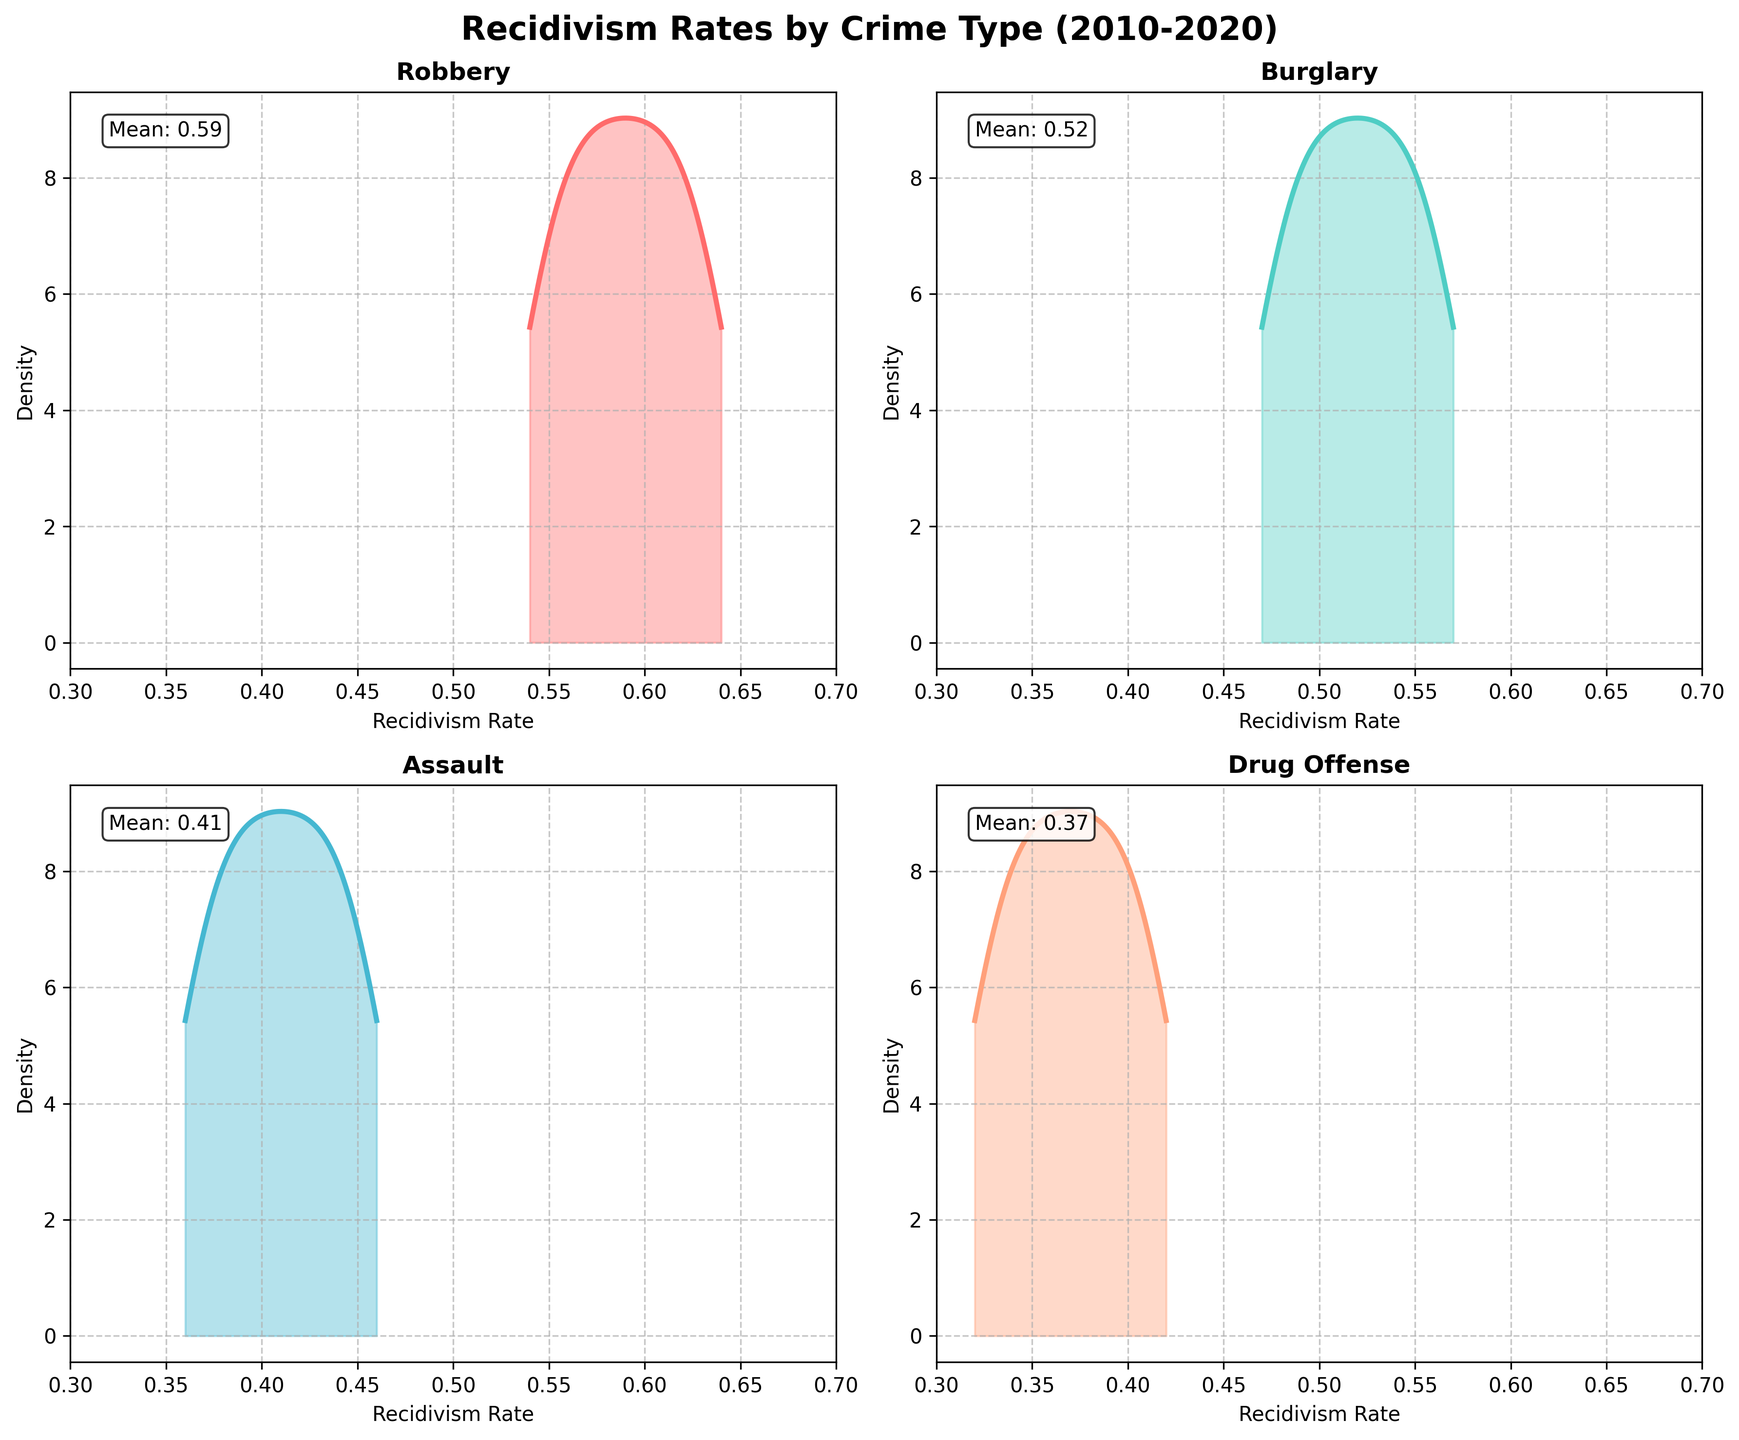What is the title of the figure? The title of the figure is mentioned at the top of the plot. It says, "Recidivism Rates by Crime Type (2010-2020)".
Answer: Recidivism Rates by Crime Type (2010-2020) What are the four crime types shown in the figure? The crime types are mentioned as separate subplots. They are titled individually as "Robbery", "Burglary", "Assault", and "Drug Offense".
Answer: Robbery, Burglary, Assault, Drug Offense Which crime type has the highest mean recidivism rate? Each subplot mentions the mean recidivism rate in a text box. By comparing these means, "Robbery" has the highest mean recidivism rate, which is around 0.60.
Answer: Robbery Which crime type has the densest peak to the left side of the recidivism rate axis? By looking at the density plots, "Drug Offense" has the densest peak towards the left side, indicating a higher density of lower recidivism rates compared to other crimes.
Answer: Drug Offense How does the recidivism rate for "Assault" change over the years? The density plot of "Assault" shows the distribution of rates over the years. The density curve being more spread indicates that recidivism rates for "Assault" have varied over the years.
Answer: Varied Among the crime types, which has the least variability in recidivism rates over the years? By observing the width and spread of the density plots, "Robbery" has a narrower and more consistent density peak, indicating less variability.
Answer: Robbery Which subplot shows a noticeable decrease in recidivism rates over the years? The "Drug Offense" subplot shows that the density peak shifts to the left over the years, indicating a noticeable decrease in recidivism rates.
Answer: Drug Offense Which crime type has a mean recidivism rate below 0.40? Each subplot has the mean mentioned in a text box. "Drug Offense" has a mean recidivism rate of 0.38, which is below 0.40.
Answer: Drug Offense What is the range of the x-axis (Recidivism Rate) in all subplots? The x-axis range can be observed in the subplots, which spans from 0.3 to 0.7.
Answer: 0.3 to 0.7 